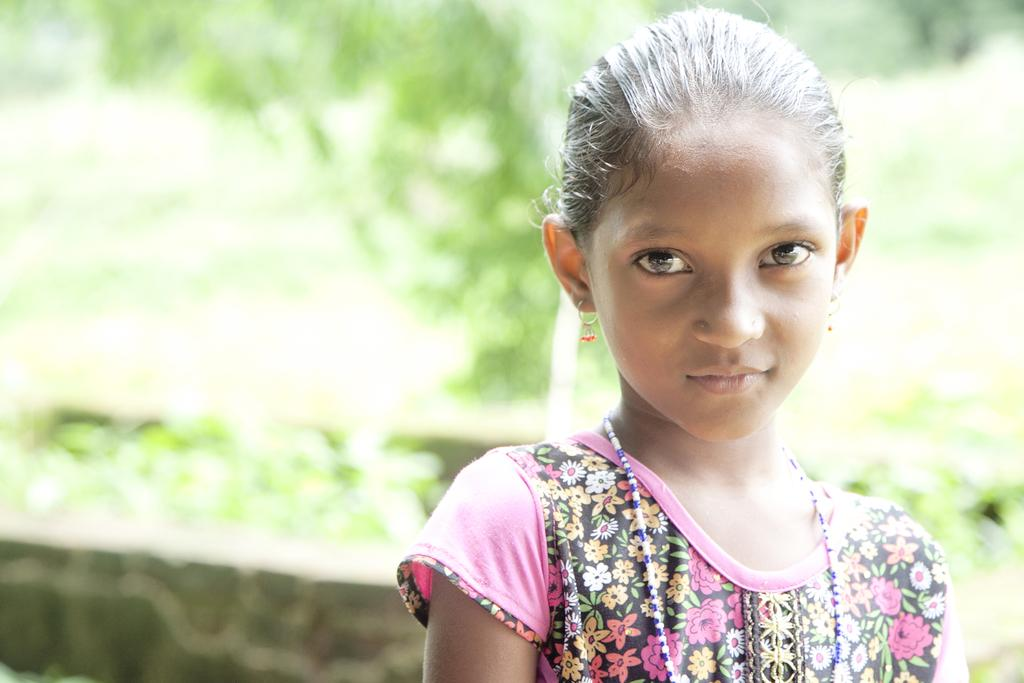What is the main subject of the image? There is a girl standing in the image. What is the girl's expression in the image? The girl is smiling in the image. Can you describe the background of the image? The background of the image is blurry. What type of process is being used to create friction in the image? There is no mention of a process or friction in the image; it features a girl standing with a blurry background. 